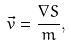<formula> <loc_0><loc_0><loc_500><loc_500>\vec { v } = \frac { \nabla S } { m } ,</formula> 